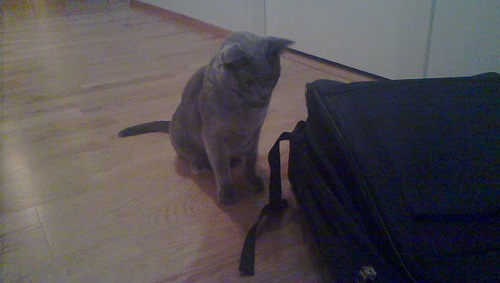Describe the objects in this image and their specific colors. I can see suitcase in purple, black, navy, and gray tones and cat in purple, black, and gray tones in this image. 